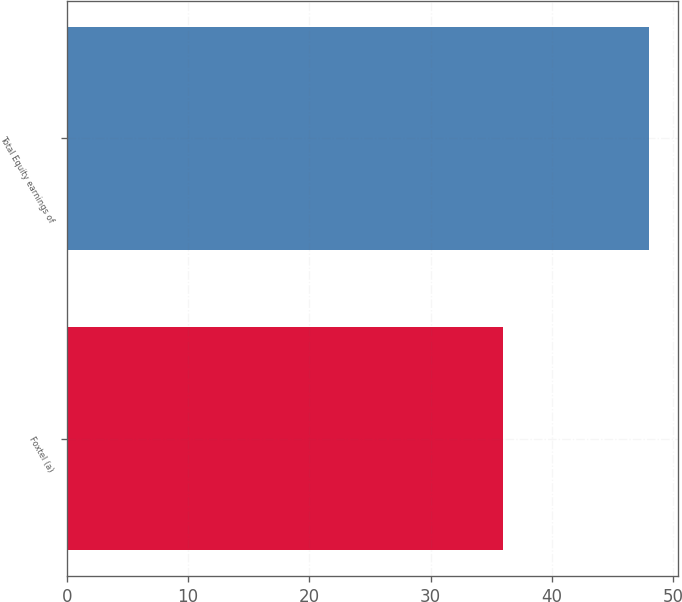<chart> <loc_0><loc_0><loc_500><loc_500><bar_chart><fcel>Foxtel (a)<fcel>Total Equity earnings of<nl><fcel>36<fcel>48<nl></chart> 